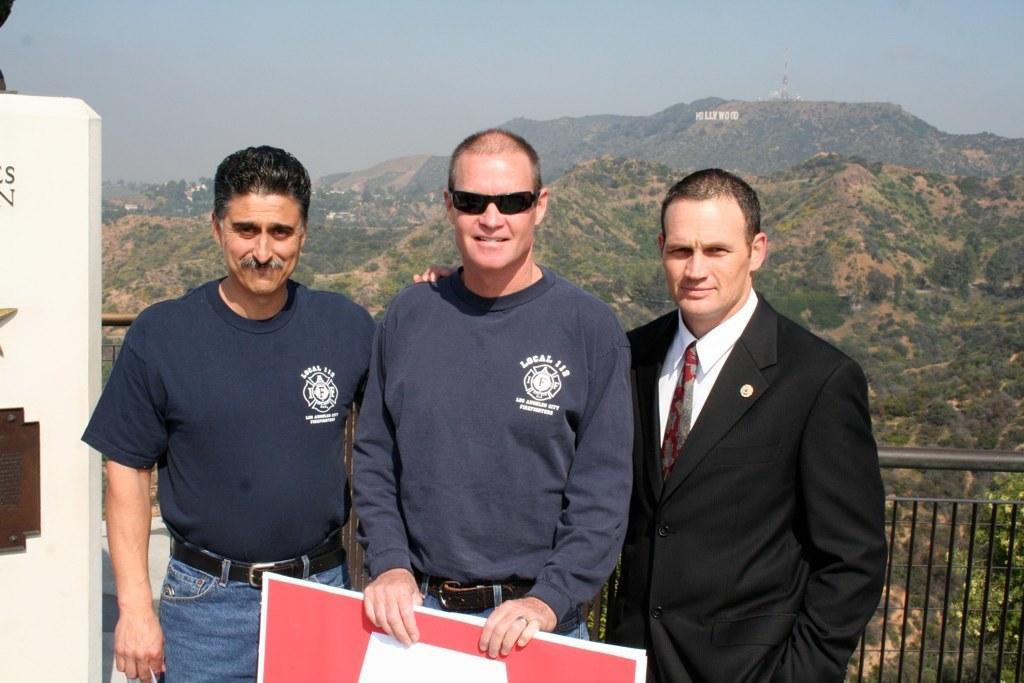Could you give a brief overview of what you see in this image? In the picture we can see three men are standing together and one man is holding a board which is red in color and beside them, we can see a white color wall and behind them, we can see a railing and far away from it, we can see hills covered with plants and behind it also we can see a hill with a name on it as HOLLY WOOD and on the top of it we can see a tower and a sky behind it. 